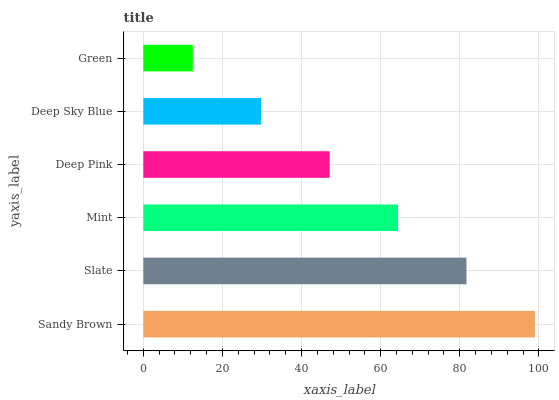Is Green the minimum?
Answer yes or no. Yes. Is Sandy Brown the maximum?
Answer yes or no. Yes. Is Slate the minimum?
Answer yes or no. No. Is Slate the maximum?
Answer yes or no. No. Is Sandy Brown greater than Slate?
Answer yes or no. Yes. Is Slate less than Sandy Brown?
Answer yes or no. Yes. Is Slate greater than Sandy Brown?
Answer yes or no. No. Is Sandy Brown less than Slate?
Answer yes or no. No. Is Mint the high median?
Answer yes or no. Yes. Is Deep Pink the low median?
Answer yes or no. Yes. Is Sandy Brown the high median?
Answer yes or no. No. Is Deep Sky Blue the low median?
Answer yes or no. No. 